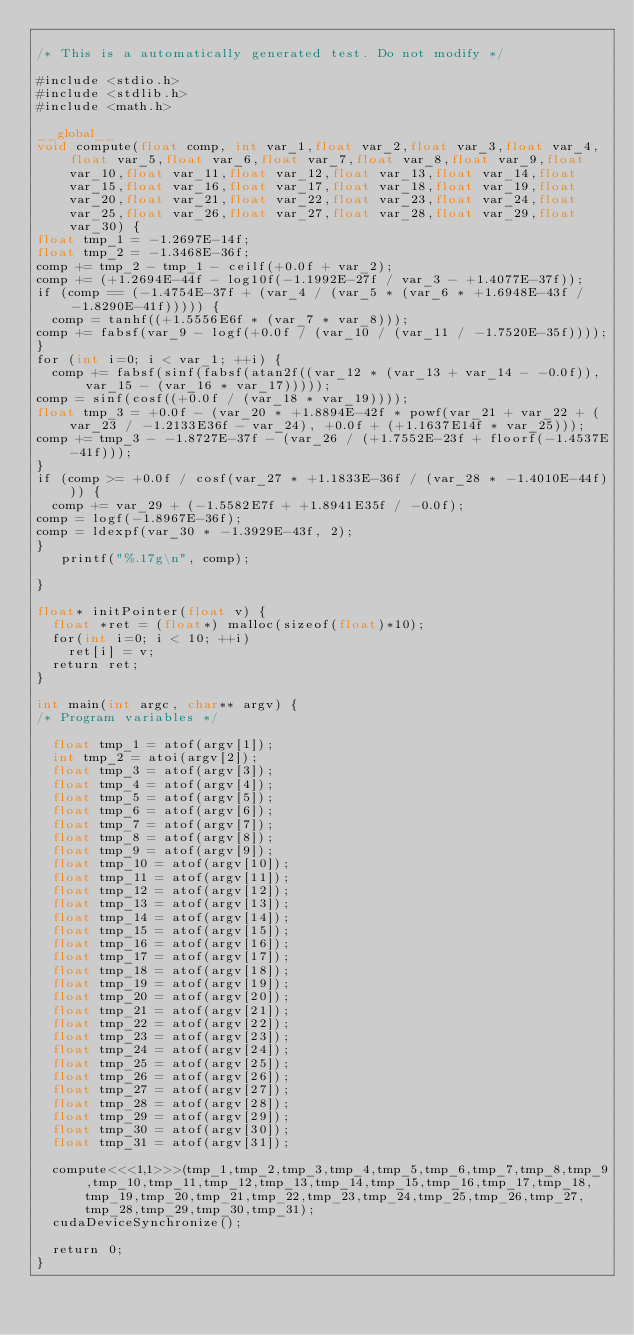Convert code to text. <code><loc_0><loc_0><loc_500><loc_500><_Cuda_>
/* This is a automatically generated test. Do not modify */

#include <stdio.h>
#include <stdlib.h>
#include <math.h>

__global__
void compute(float comp, int var_1,float var_2,float var_3,float var_4,float var_5,float var_6,float var_7,float var_8,float var_9,float var_10,float var_11,float var_12,float var_13,float var_14,float var_15,float var_16,float var_17,float var_18,float var_19,float var_20,float var_21,float var_22,float var_23,float var_24,float var_25,float var_26,float var_27,float var_28,float var_29,float var_30) {
float tmp_1 = -1.2697E-14f;
float tmp_2 = -1.3468E-36f;
comp += tmp_2 - tmp_1 - ceilf(+0.0f + var_2);
comp += (+1.2694E-44f - log10f(-1.1992E-27f / var_3 - +1.4077E-37f));
if (comp == (-1.4754E-37f + (var_4 / (var_5 * (var_6 * +1.6948E-43f / -1.8290E-41f))))) {
  comp = tanhf((+1.5556E6f * (var_7 * var_8)));
comp += fabsf(var_9 - logf(+0.0f / (var_10 / (var_11 / -1.7520E-35f))));
}
for (int i=0; i < var_1; ++i) {
  comp += fabsf(sinf(fabsf(atan2f((var_12 * (var_13 + var_14 - -0.0f)), var_15 - (var_16 * var_17)))));
comp = sinf(cosf((+0.0f / (var_18 * var_19))));
float tmp_3 = +0.0f - (var_20 * +1.8894E-42f * powf(var_21 + var_22 + (var_23 / -1.2133E36f - var_24), +0.0f + (+1.1637E14f * var_25)));
comp += tmp_3 - -1.8727E-37f - (var_26 / (+1.7552E-23f + floorf(-1.4537E-41f)));
}
if (comp >= +0.0f / cosf(var_27 * +1.1833E-36f / (var_28 * -1.4010E-44f))) {
  comp += var_29 + (-1.5582E7f + +1.8941E35f / -0.0f);
comp = logf(-1.8967E-36f);
comp = ldexpf(var_30 * -1.3929E-43f, 2);
}
   printf("%.17g\n", comp);

}

float* initPointer(float v) {
  float *ret = (float*) malloc(sizeof(float)*10);
  for(int i=0; i < 10; ++i)
    ret[i] = v;
  return ret;
}

int main(int argc, char** argv) {
/* Program variables */

  float tmp_1 = atof(argv[1]);
  int tmp_2 = atoi(argv[2]);
  float tmp_3 = atof(argv[3]);
  float tmp_4 = atof(argv[4]);
  float tmp_5 = atof(argv[5]);
  float tmp_6 = atof(argv[6]);
  float tmp_7 = atof(argv[7]);
  float tmp_8 = atof(argv[8]);
  float tmp_9 = atof(argv[9]);
  float tmp_10 = atof(argv[10]);
  float tmp_11 = atof(argv[11]);
  float tmp_12 = atof(argv[12]);
  float tmp_13 = atof(argv[13]);
  float tmp_14 = atof(argv[14]);
  float tmp_15 = atof(argv[15]);
  float tmp_16 = atof(argv[16]);
  float tmp_17 = atof(argv[17]);
  float tmp_18 = atof(argv[18]);
  float tmp_19 = atof(argv[19]);
  float tmp_20 = atof(argv[20]);
  float tmp_21 = atof(argv[21]);
  float tmp_22 = atof(argv[22]);
  float tmp_23 = atof(argv[23]);
  float tmp_24 = atof(argv[24]);
  float tmp_25 = atof(argv[25]);
  float tmp_26 = atof(argv[26]);
  float tmp_27 = atof(argv[27]);
  float tmp_28 = atof(argv[28]);
  float tmp_29 = atof(argv[29]);
  float tmp_30 = atof(argv[30]);
  float tmp_31 = atof(argv[31]);

  compute<<<1,1>>>(tmp_1,tmp_2,tmp_3,tmp_4,tmp_5,tmp_6,tmp_7,tmp_8,tmp_9,tmp_10,tmp_11,tmp_12,tmp_13,tmp_14,tmp_15,tmp_16,tmp_17,tmp_18,tmp_19,tmp_20,tmp_21,tmp_22,tmp_23,tmp_24,tmp_25,tmp_26,tmp_27,tmp_28,tmp_29,tmp_30,tmp_31);
  cudaDeviceSynchronize();

  return 0;
}
</code> 